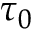<formula> <loc_0><loc_0><loc_500><loc_500>\tau _ { 0 }</formula> 